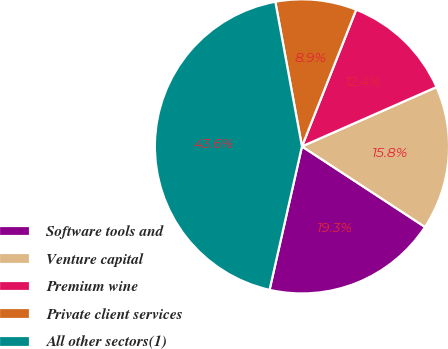<chart> <loc_0><loc_0><loc_500><loc_500><pie_chart><fcel>Software tools and<fcel>Venture capital<fcel>Premium wine<fcel>Private client services<fcel>All other sectors(1)<nl><fcel>19.31%<fcel>15.84%<fcel>12.38%<fcel>8.91%<fcel>43.57%<nl></chart> 